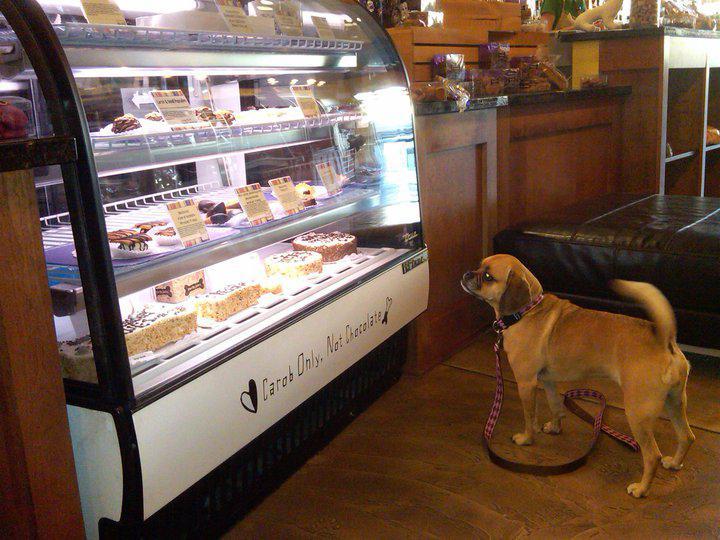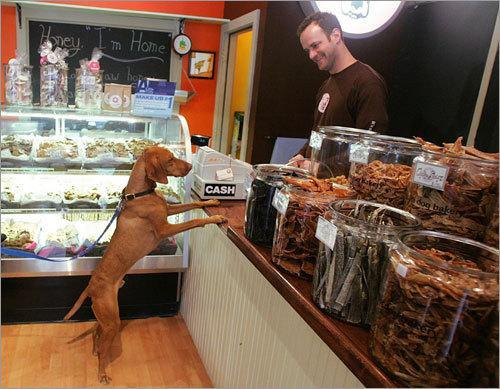The first image is the image on the left, the second image is the image on the right. Assess this claim about the two images: "In one of the images, a dog is looking at the cakes.". Correct or not? Answer yes or no. Yes. The first image is the image on the left, the second image is the image on the right. Assess this claim about the two images: "A real dog is standing on all fours in front of a display case in one image.". Correct or not? Answer yes or no. Yes. 